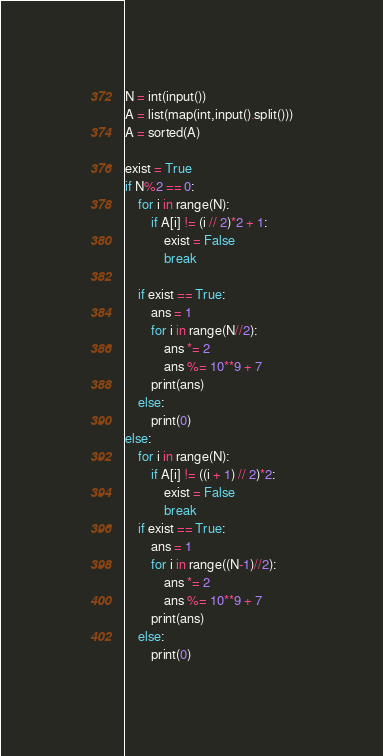<code> <loc_0><loc_0><loc_500><loc_500><_Python_>N = int(input())
A = list(map(int,input().split()))
A = sorted(A)

exist = True
if N%2 == 0:
    for i in range(N):
        if A[i] != (i // 2)*2 + 1:
            exist = False
            break
    
    if exist == True:
        ans = 1
        for i in range(N//2):
            ans *= 2
            ans %= 10**9 + 7
        print(ans)
    else:
        print(0)
else:
    for i in range(N):
        if A[i] != ((i + 1) // 2)*2:
            exist = False
            break
    if exist == True:
        ans = 1
        for i in range((N-1)//2):
            ans *= 2
            ans %= 10**9 + 7
        print(ans)
    else:
        print(0)</code> 